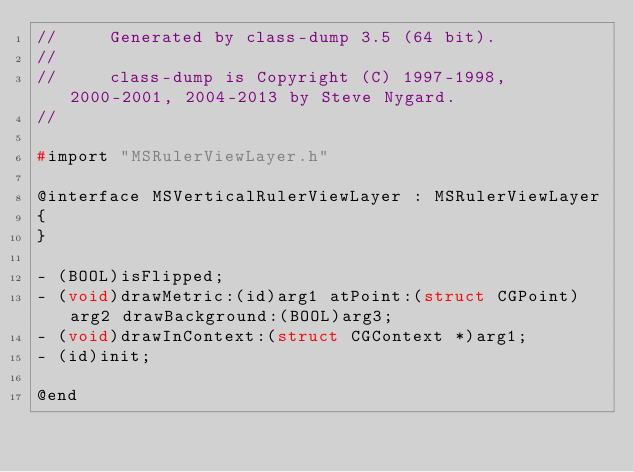<code> <loc_0><loc_0><loc_500><loc_500><_C_>//     Generated by class-dump 3.5 (64 bit).
//
//     class-dump is Copyright (C) 1997-1998, 2000-2001, 2004-2013 by Steve Nygard.
//

#import "MSRulerViewLayer.h"

@interface MSVerticalRulerViewLayer : MSRulerViewLayer
{
}

- (BOOL)isFlipped;
- (void)drawMetric:(id)arg1 atPoint:(struct CGPoint)arg2 drawBackground:(BOOL)arg3;
- (void)drawInContext:(struct CGContext *)arg1;
- (id)init;

@end

</code> 